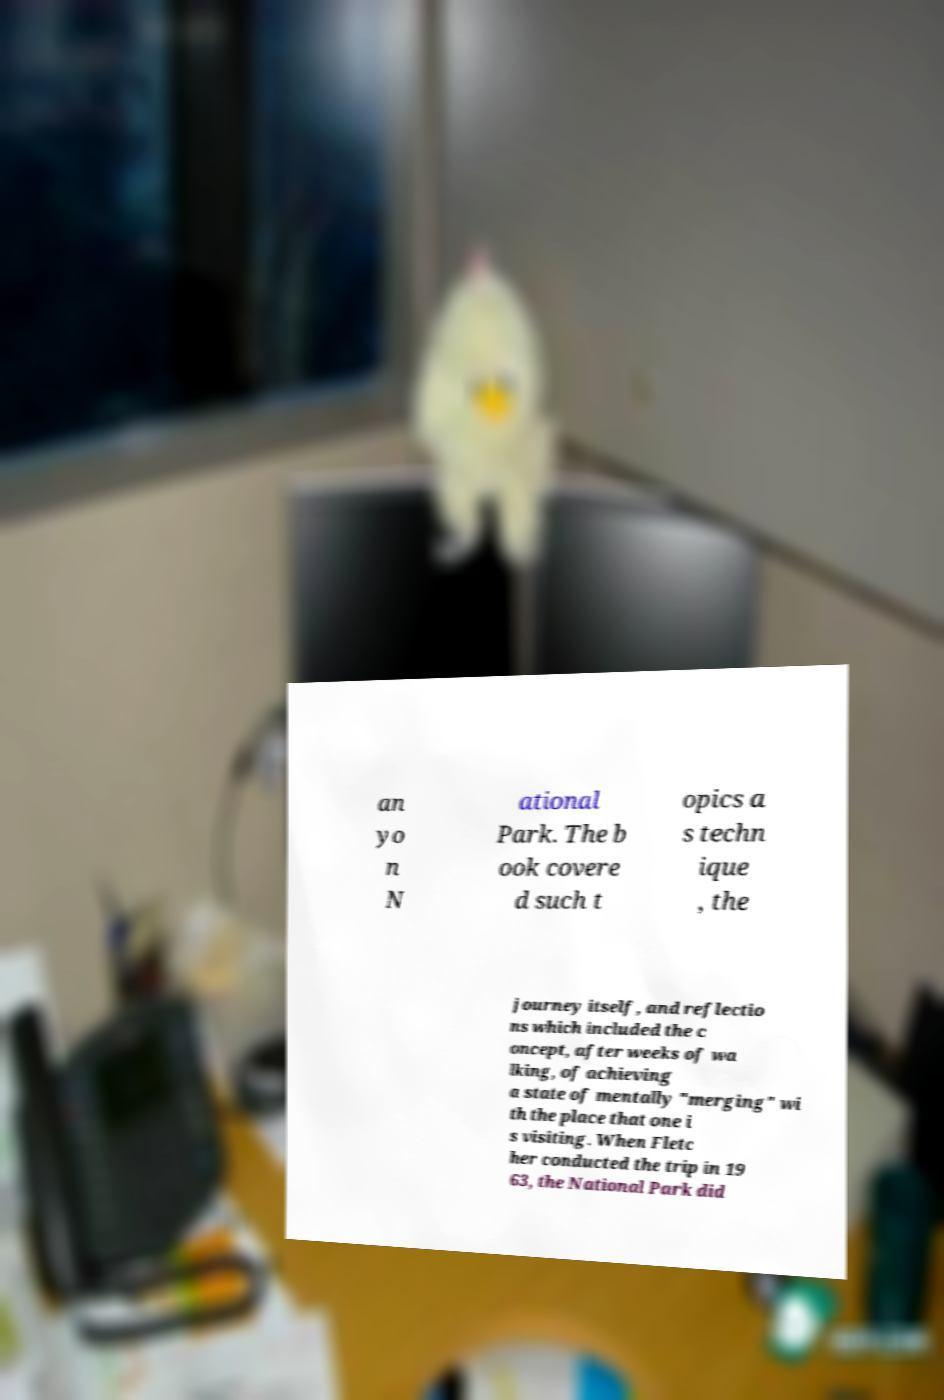Can you read and provide the text displayed in the image?This photo seems to have some interesting text. Can you extract and type it out for me? an yo n N ational Park. The b ook covere d such t opics a s techn ique , the journey itself, and reflectio ns which included the c oncept, after weeks of wa lking, of achieving a state of mentally "merging" wi th the place that one i s visiting. When Fletc her conducted the trip in 19 63, the National Park did 